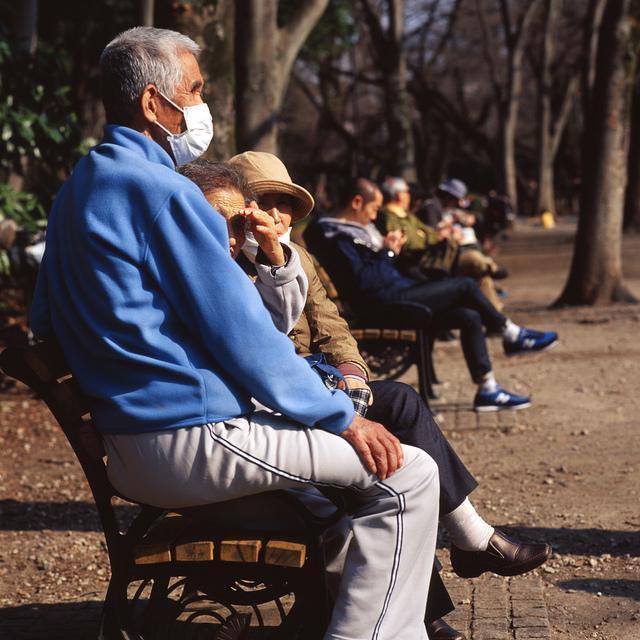What should the woman sitting in the middle wear for protection?
Make your selection from the four choices given to correctly answer the question.
Options: Scarf, hat, sunglasses, mittens. Sunglasses. 